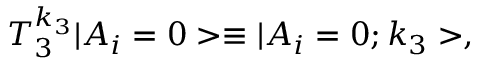<formula> <loc_0><loc_0><loc_500><loc_500>T _ { 3 } ^ { k _ { 3 } } | A _ { i } = 0 > \equiv | A _ { i } = 0 ; k _ { 3 } > ,</formula> 